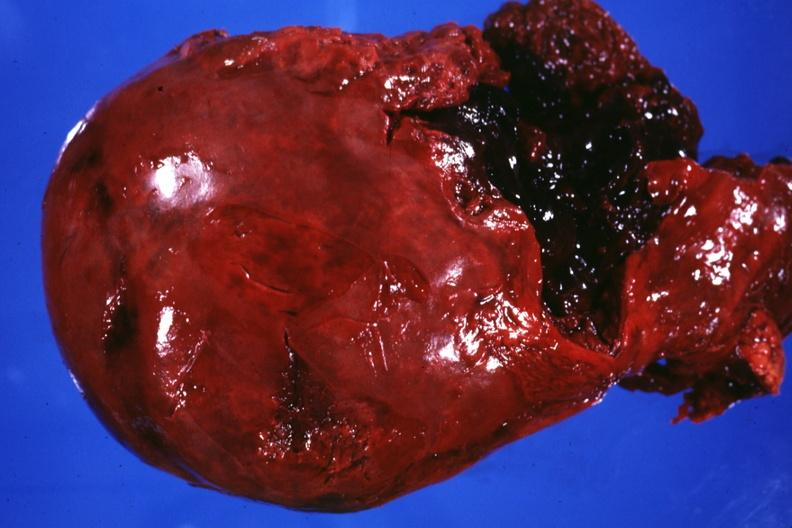what is present?
Answer the question using a single word or phrase. Hepatobiliary 